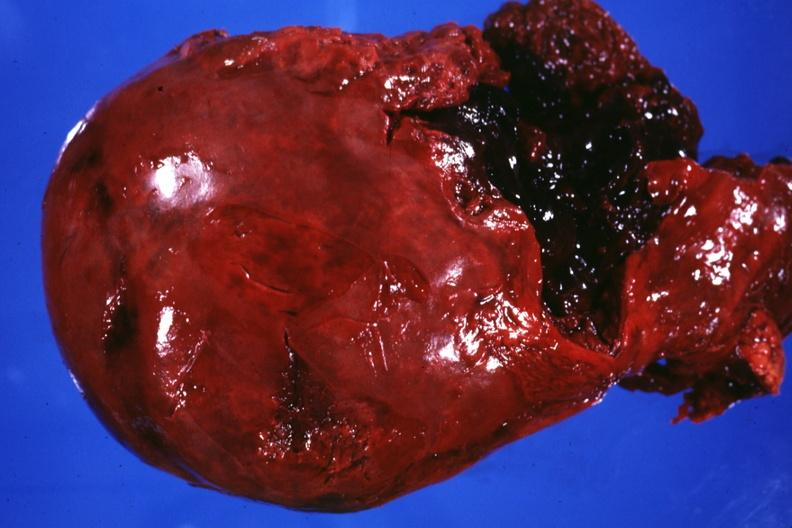what is present?
Answer the question using a single word or phrase. Hepatobiliary 